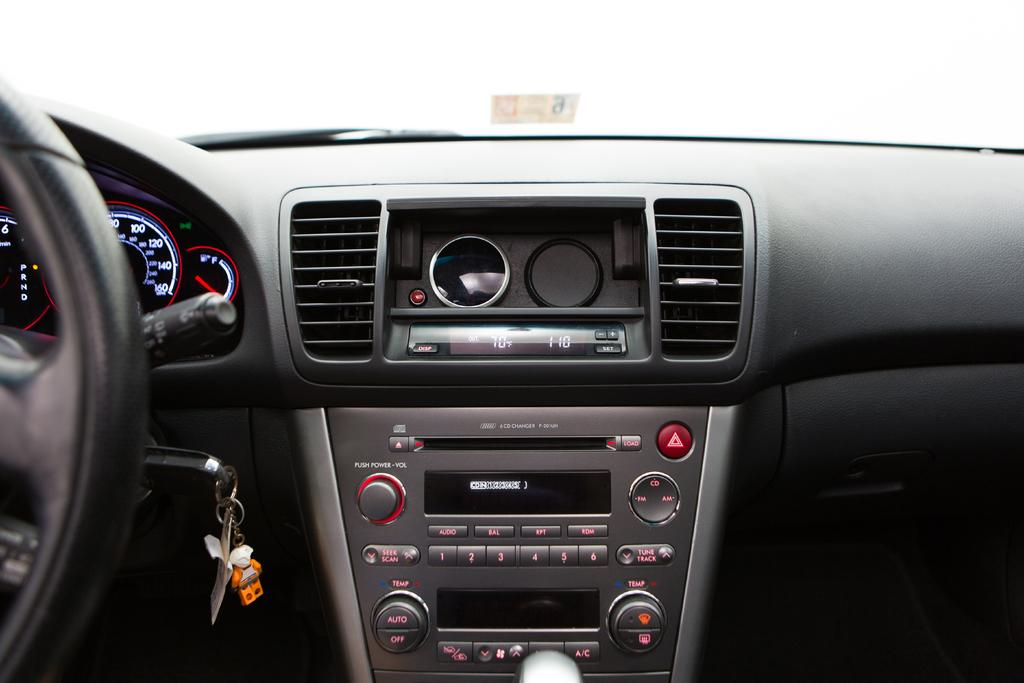What type of location is depicted in the image? The image is an inside view of a car. Where is the steering wheel located in the car? The steering wheel is on the left side in the image. Can you describe any accessories visible in the car? Yes, a keychain is visible in the car. What other unspecified items can be seen in the car? There are other unspecified items in the car, but their details are not provided in the facts. What type of building is being taught in the car? There is no building or teaching activity depicted in the image; it is an inside view of a car. What type of chain is holding the car together? The image does not show any chains holding the car together; it is a regular car with standard construction. 